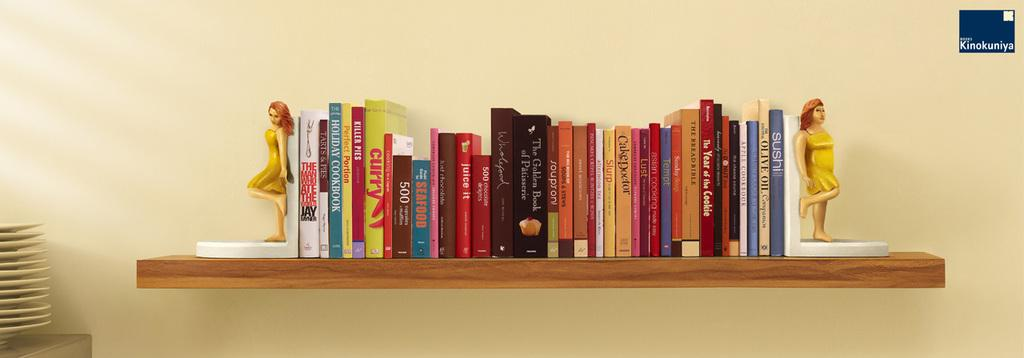<image>
Describe the image concisely. Book shelf with many books including one titled SLURP. 